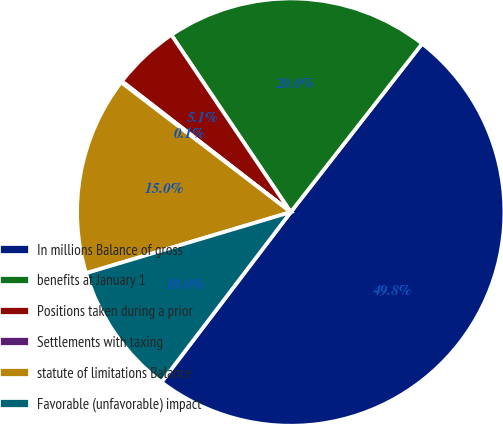Convert chart to OTSL. <chart><loc_0><loc_0><loc_500><loc_500><pie_chart><fcel>In millions Balance of gross<fcel>benefits at January 1<fcel>Positions taken during a prior<fcel>Settlements with taxing<fcel>statute of limitations Balance<fcel>Favorable (unfavorable) impact<nl><fcel>49.8%<fcel>19.98%<fcel>5.07%<fcel>0.1%<fcel>15.01%<fcel>10.04%<nl></chart> 